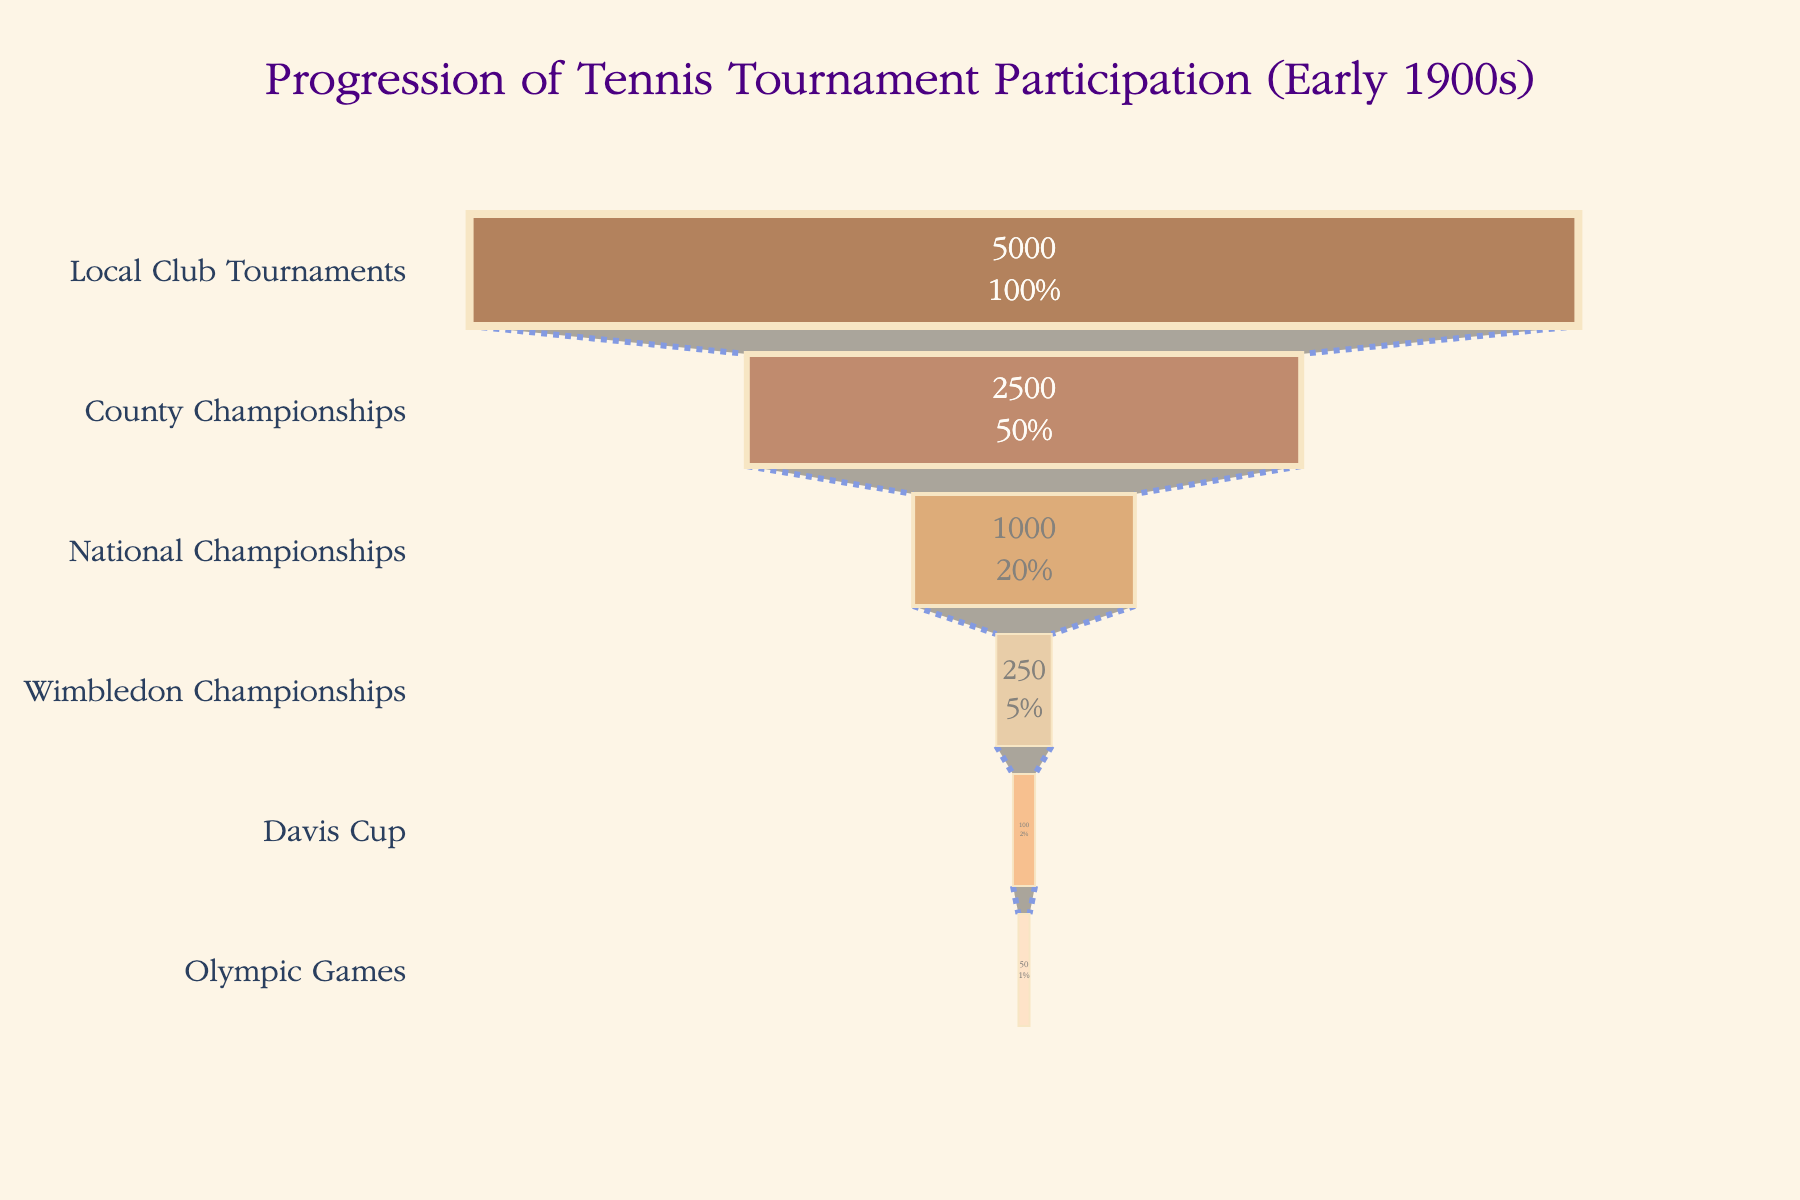What's the title of this figure? The title is typically displayed at the top of the figure. The provided information specifies that the title is "Progression of Tennis Tournament Participation (Early 1900s)."
Answer: Progression of Tennis Tournament Participation (Early 1900s) How many stages are represented in the funnel chart? By looking at the funnel chart, we can count the number of layers or stages. Each stage corresponds to a different part of the tennis tournament progression.
Answer: 6 Which stage has the highest number of participants? By examining the width of each funnel section, we can see that the widest section represents the largest number of participants. This is the base of the funnel.
Answer: Local Club Tournaments What is the percentage of participants advancing from County Championships to National Championships? To calculate the percentage, we need to divide the number of participants in the National Championships (1000) by the number of participants in the County Championships (2500), and then multiply by 100.
Answer: 40% How many participants are there in both the Wimbledon Championships and the Davis Cup combined? By adding the number of participants in the Wimbledon Championships (250) to those in the Davis Cup (100), we get the total number of participants in these two stages.
Answer: 350 Which two stages have the smallest difference in the number of participants? We need to calculate the difference in participant numbers between consecutive stages and then find the pair with the smallest difference. The smallest difference is between the Davis Cup (100) and the Olympic Games (50), which is 50 participants.
Answer: Davis Cup and Olympic Games How many participants progress from Local Club Tournaments to the Olympic Games? We look at the participant numbers at the entry stage (Local Club Tournaments) and the final stage (Olympic Games) to see the total reduction in numbers and thus how many make it through to the end.
Answer: 50 What percentage of initial participants make it to Wimbledon Championships? To calculate the percentage, divide the number of Wimbledon Championships participants (250) by the number of initial participants (Local Club Tournaments, 5000), and multiply by 100.
Answer: 5% Which stage sees a reduction to exactly half from the previous stage? By examining the participant numbers between each consecutive stage, identify where the participants halve. This happens between Local Club Tournaments (5000) and County Championships (2500).
Answer: County Championships What is the average number of participants across all stages? To find this, sum all the participants in each stage and then divide by the number of stages. The sum is 8900 and there are 6 stages, so the average is 8900/6.
Answer: 1483.33 